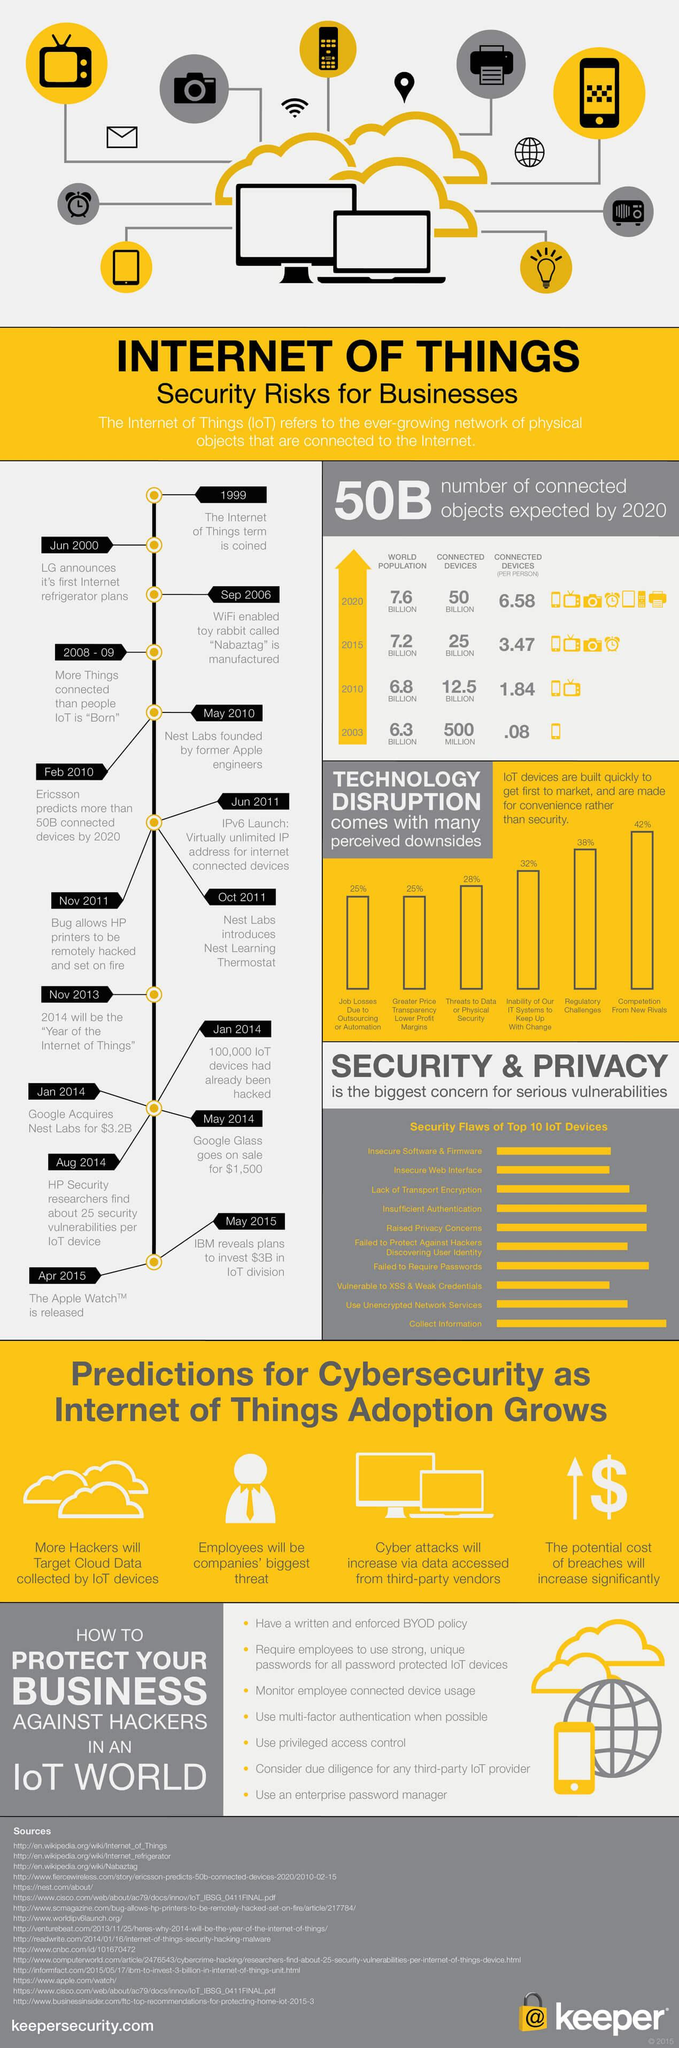Outline some significant characteristics in this image. Technology disruption poses the biggest challenge in competition from new rivals. There are 16 listed sources in total. 